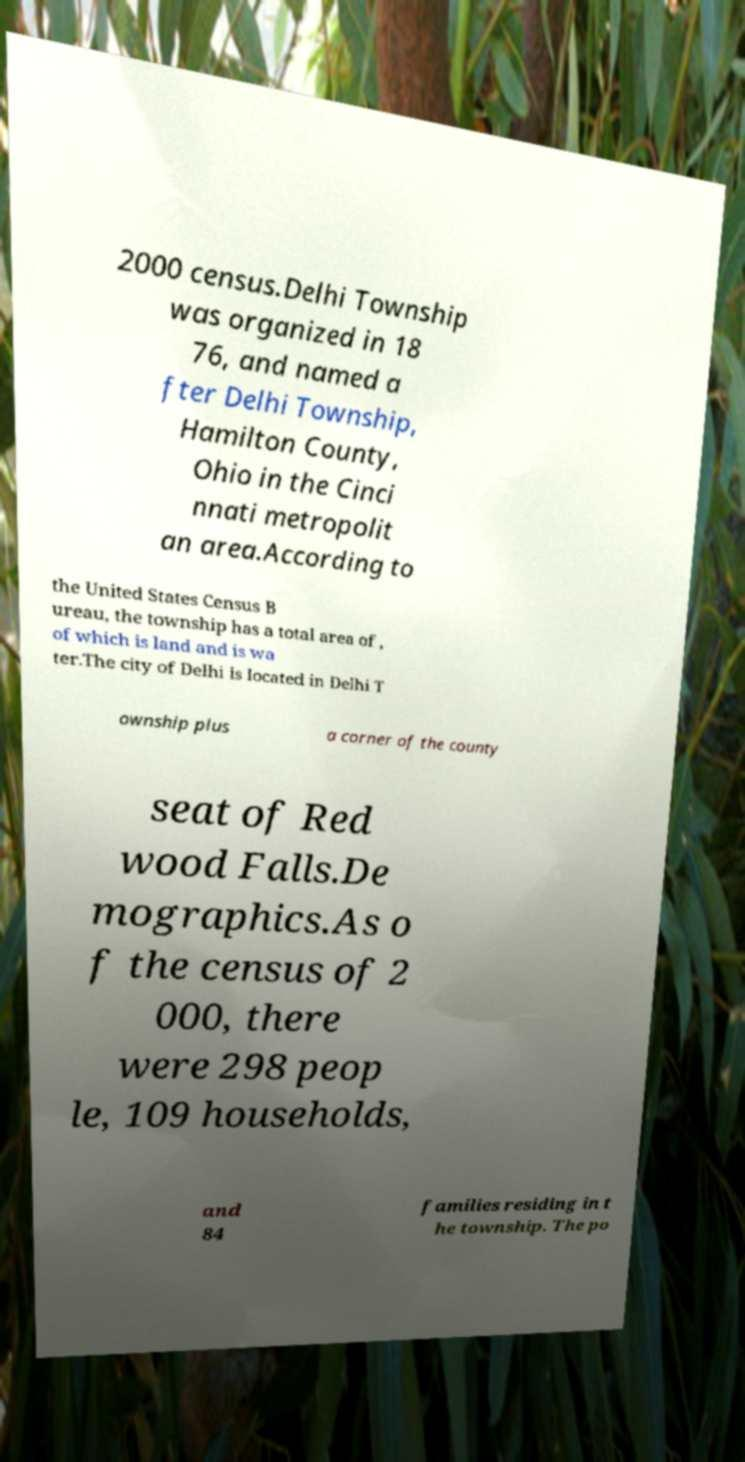What messages or text are displayed in this image? I need them in a readable, typed format. 2000 census.Delhi Township was organized in 18 76, and named a fter Delhi Township, Hamilton County, Ohio in the Cinci nnati metropolit an area.According to the United States Census B ureau, the township has a total area of , of which is land and is wa ter.The city of Delhi is located in Delhi T ownship plus a corner of the county seat of Red wood Falls.De mographics.As o f the census of 2 000, there were 298 peop le, 109 households, and 84 families residing in t he township. The po 